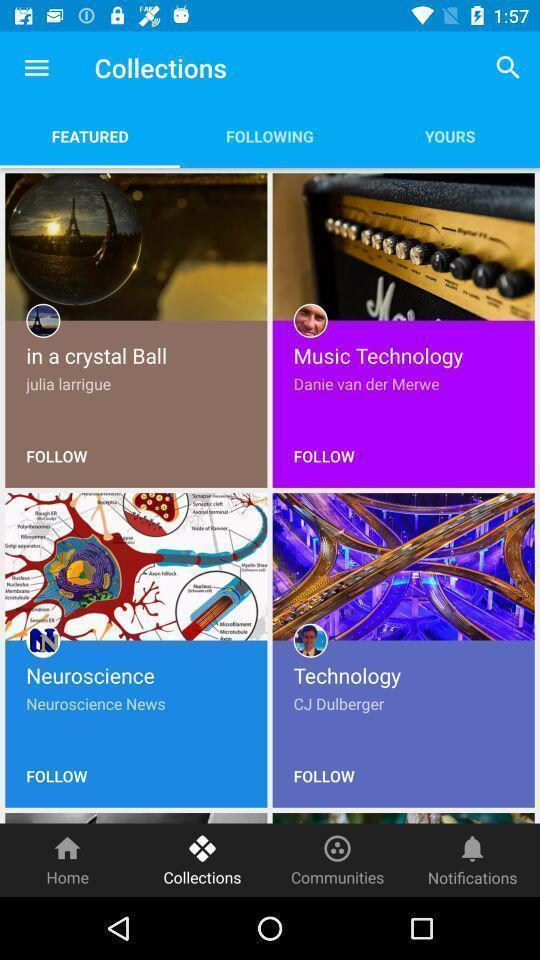Provide a description of this screenshot. Screen displaying multiple topics with names and pictures. 